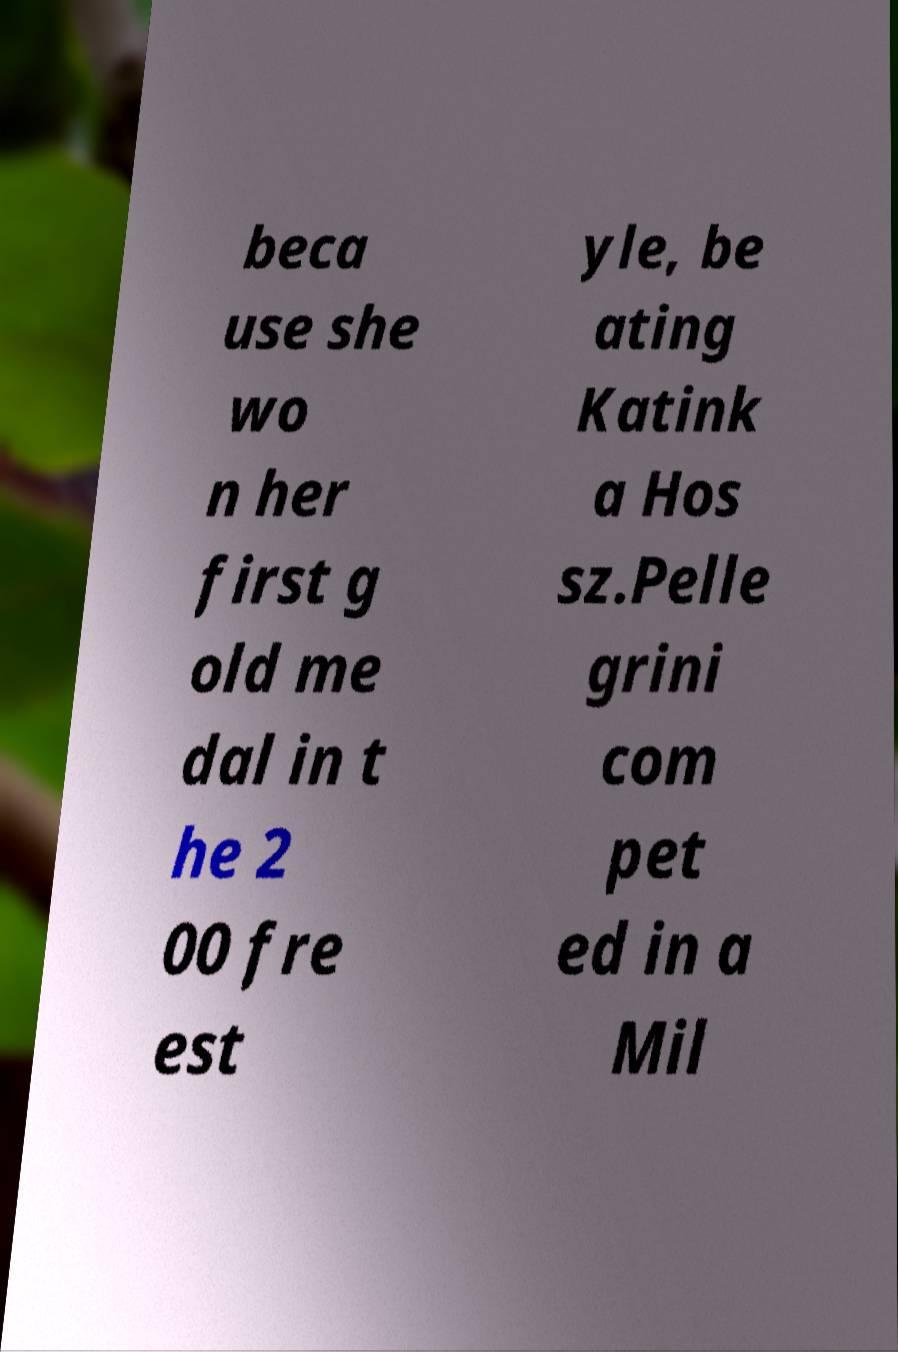Could you extract and type out the text from this image? beca use she wo n her first g old me dal in t he 2 00 fre est yle, be ating Katink a Hos sz.Pelle grini com pet ed in a Mil 